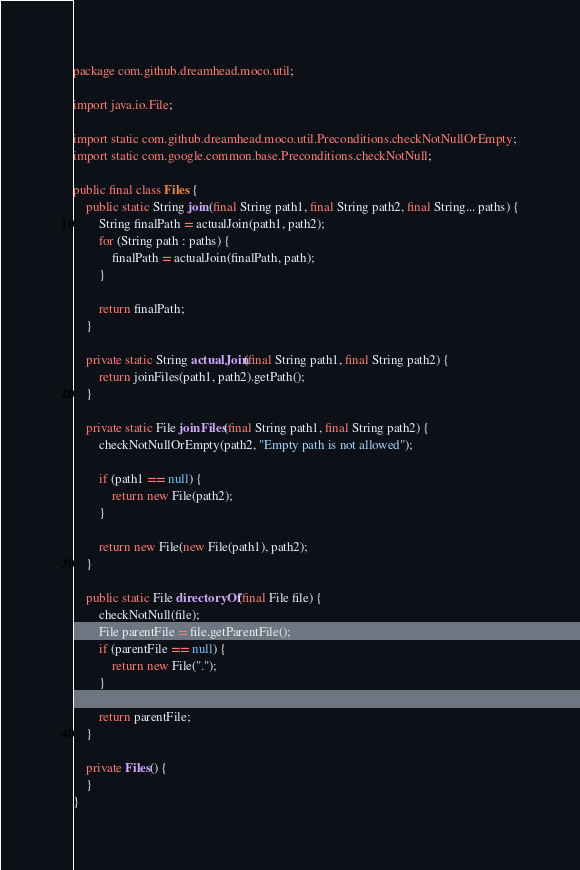Convert code to text. <code><loc_0><loc_0><loc_500><loc_500><_Java_>package com.github.dreamhead.moco.util;

import java.io.File;

import static com.github.dreamhead.moco.util.Preconditions.checkNotNullOrEmpty;
import static com.google.common.base.Preconditions.checkNotNull;

public final class Files {
    public static String join(final String path1, final String path2, final String... paths) {
        String finalPath = actualJoin(path1, path2);
        for (String path : paths) {
            finalPath = actualJoin(finalPath, path);
        }

        return finalPath;
    }

    private static String actualJoin(final String path1, final String path2) {
        return joinFiles(path1, path2).getPath();
    }

    private static File joinFiles(final String path1, final String path2) {
        checkNotNullOrEmpty(path2, "Empty path is not allowed");

        if (path1 == null) {
            return new File(path2);
        }

        return new File(new File(path1), path2);
    }

    public static File directoryOf(final File file) {
        checkNotNull(file);
        File parentFile = file.getParentFile();
        if (parentFile == null) {
            return new File(".");
        }

        return parentFile;
    }

    private Files() {
    }
}
</code> 